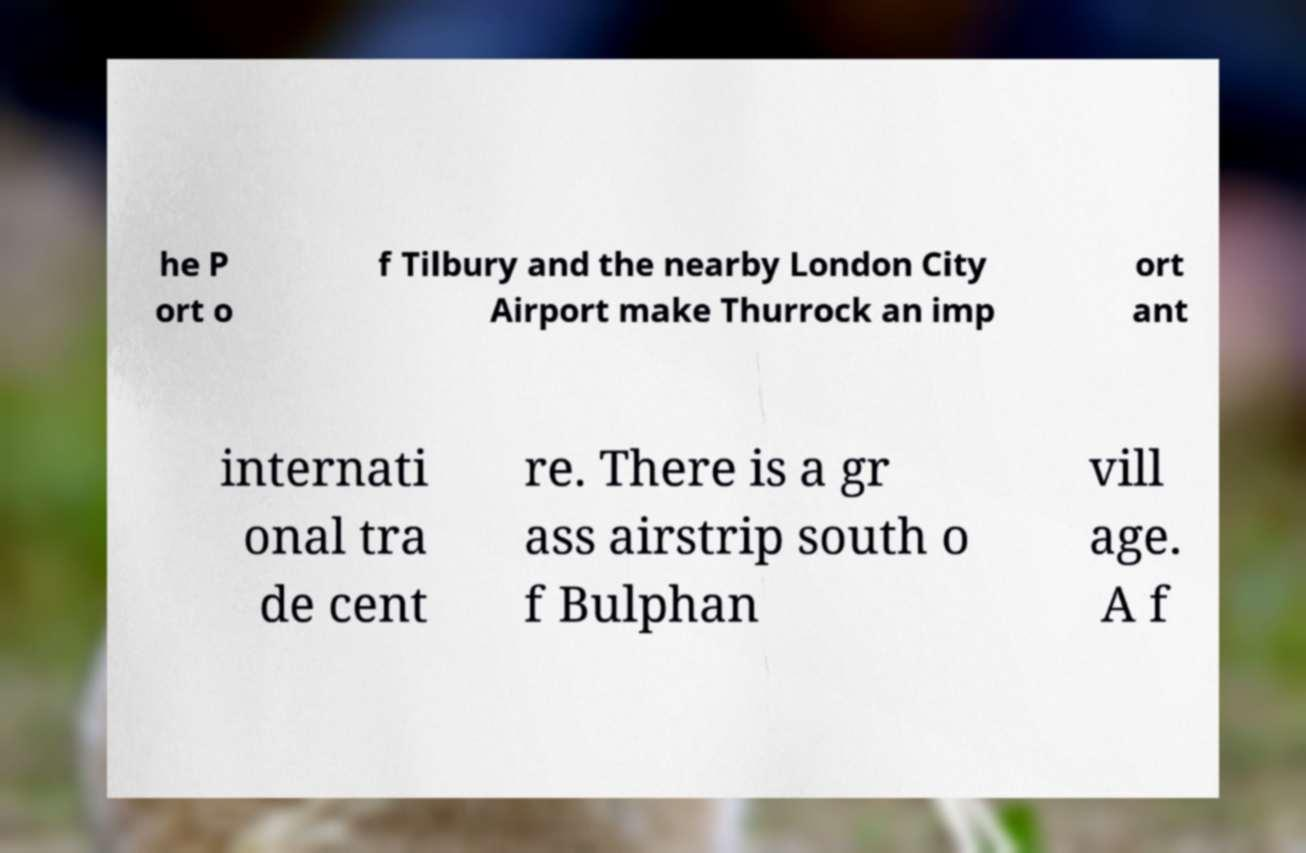Could you extract and type out the text from this image? he P ort o f Tilbury and the nearby London City Airport make Thurrock an imp ort ant internati onal tra de cent re. There is a gr ass airstrip south o f Bulphan vill age. A f 